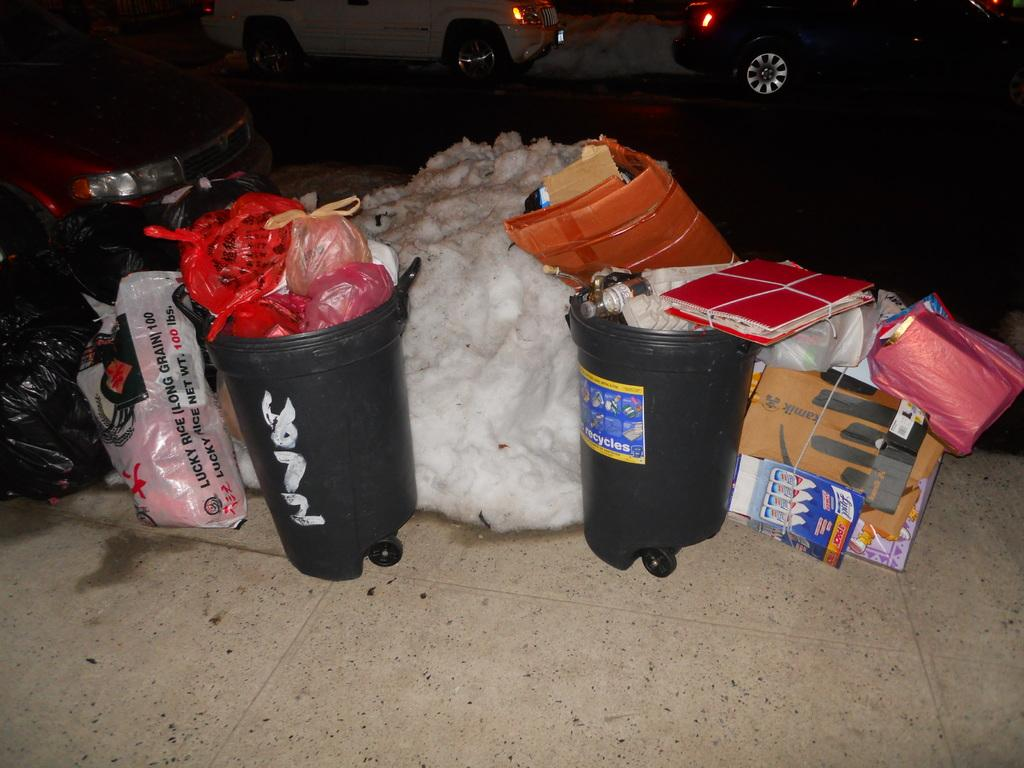<image>
Relay a brief, clear account of the picture shown. A pile of trash is on a sidewalk and one of the bags says Lucky Rice. 